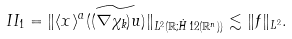<formula> <loc_0><loc_0><loc_500><loc_500>I I _ { 1 } = \| \langle x \rangle ^ { a } ( \widetilde { ( \nabla \chi _ { k } ) u } ) \| _ { L ^ { 2 } ( \mathbb { R } ; \dot { H } ^ { } { 1 } 2 ( \mathbb { R } ^ { n } ) ) } \lesssim \| f \| _ { L ^ { 2 } } .</formula> 